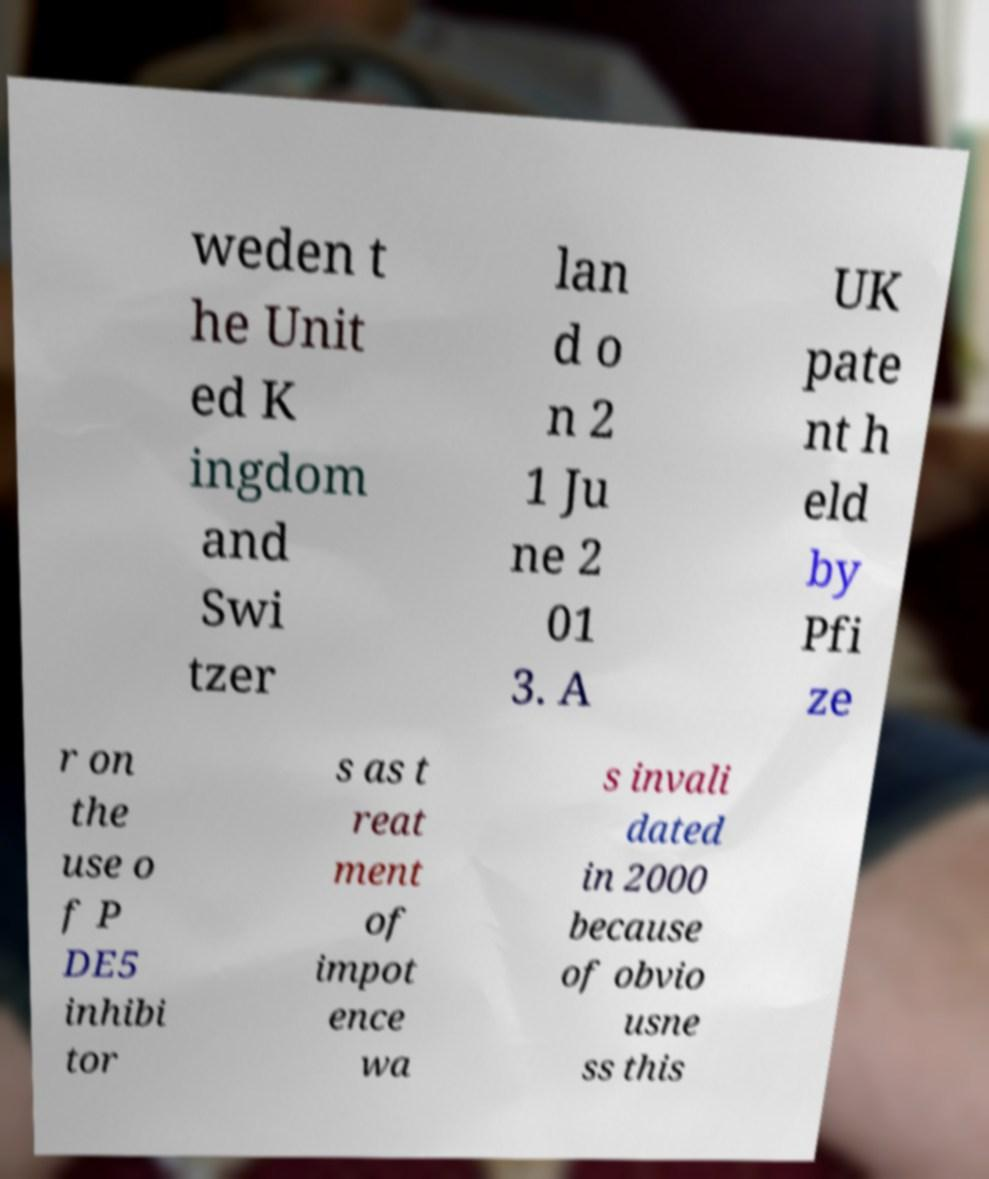Please read and relay the text visible in this image. What does it say? weden t he Unit ed K ingdom and Swi tzer lan d o n 2 1 Ju ne 2 01 3. A UK pate nt h eld by Pfi ze r on the use o f P DE5 inhibi tor s as t reat ment of impot ence wa s invali dated in 2000 because of obvio usne ss this 